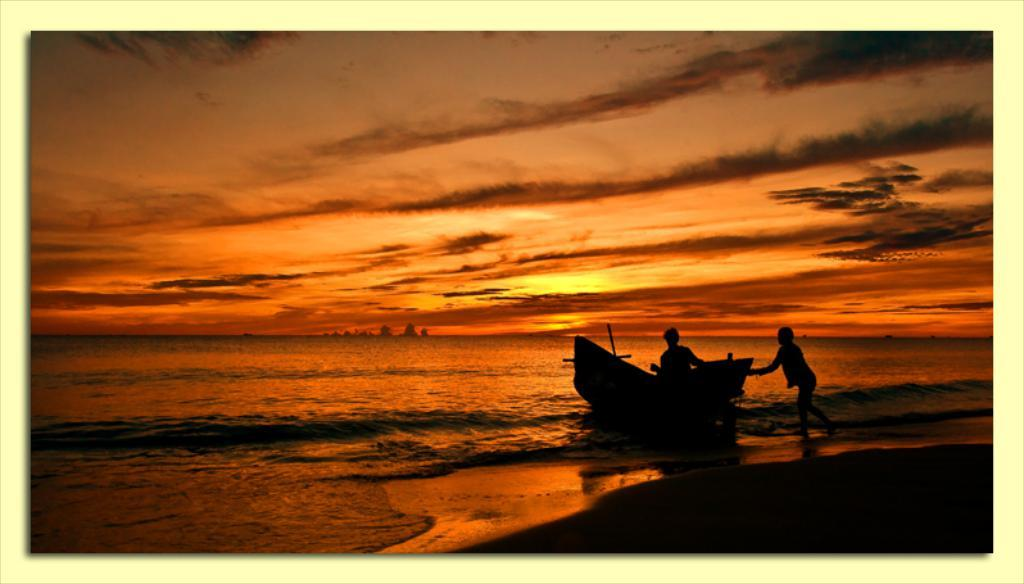What is the main subject of the image? There is a person sitting in a boat in the image. Can you describe the person standing behind the boat? There is a person standing behind the boat in the image. What type of environment is depicted in the background? The background of the image includes water. What is the color of the sky in the image? The sky in the background of the image has an orange color. What type of stage can be seen in the image? There is no stage present in the image; it features a person sitting in a boat and another person standing behind the boat in a water environment. 